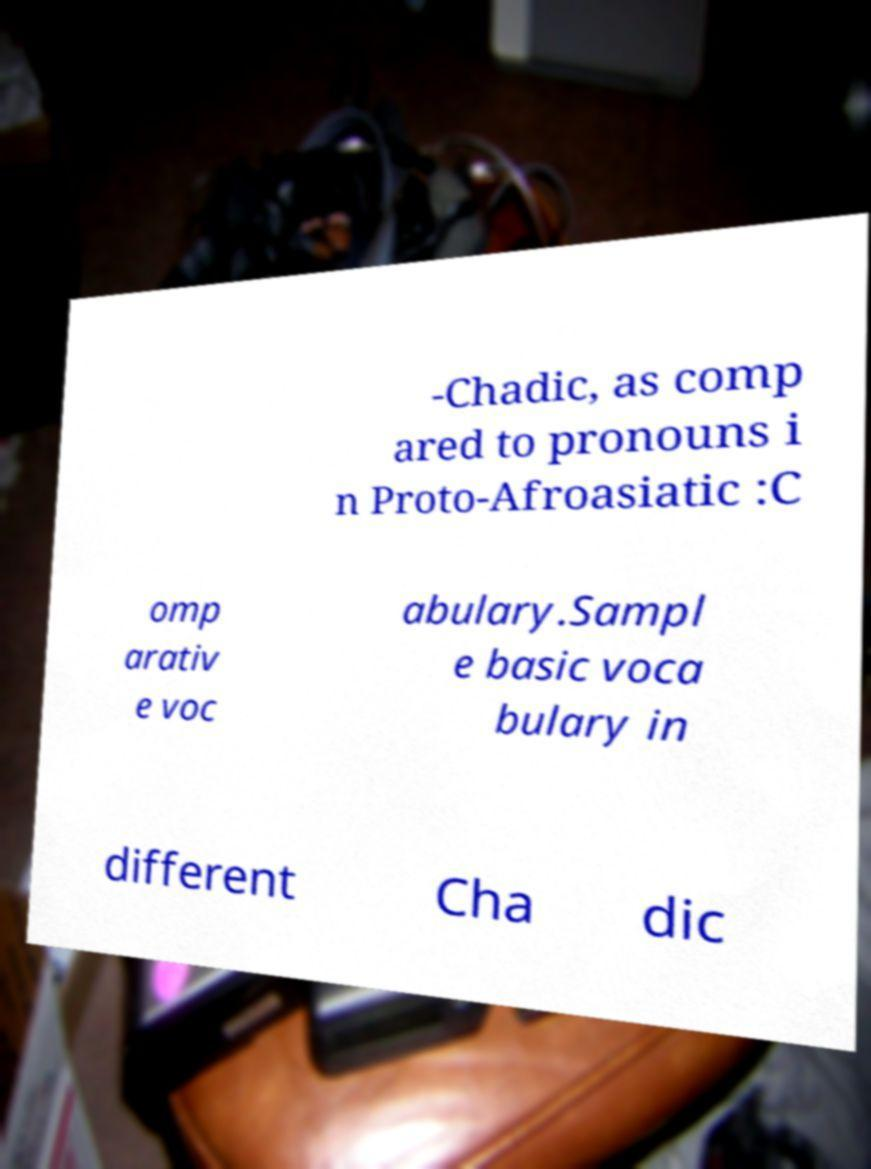Please identify and transcribe the text found in this image. -Chadic, as comp ared to pronouns i n Proto-Afroasiatic :C omp arativ e voc abulary.Sampl e basic voca bulary in different Cha dic 